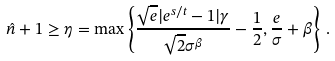Convert formula to latex. <formula><loc_0><loc_0><loc_500><loc_500>\hat { n } + 1 \geq \eta = \max \left \{ \frac { \sqrt { e } | e ^ { s / t } - 1 | \gamma } { \sqrt { 2 } \sigma ^ { \beta } } - \frac { 1 } { 2 } , \frac { e } { \sigma } + \beta \right \} \, .</formula> 